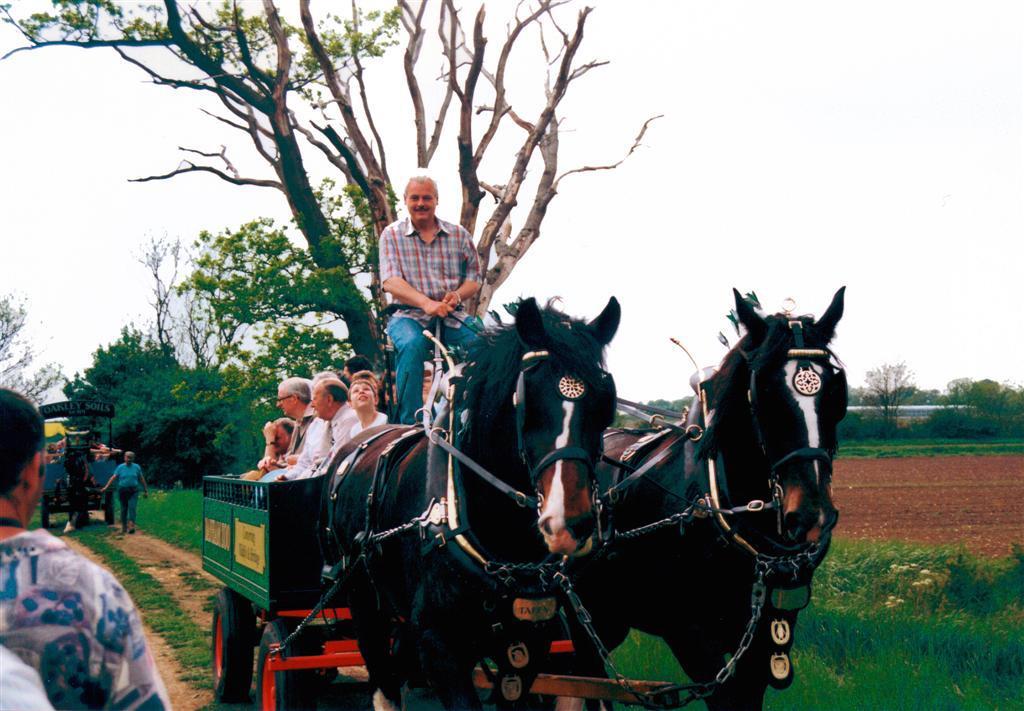How would you summarize this image in a sentence or two? The image is outside of the city. There are group of people sitting on cart in middle there is a man who is riding two horses. On right side we can see a land in background we can see a man who is walking. From left to right there are some trees and sky on top. 